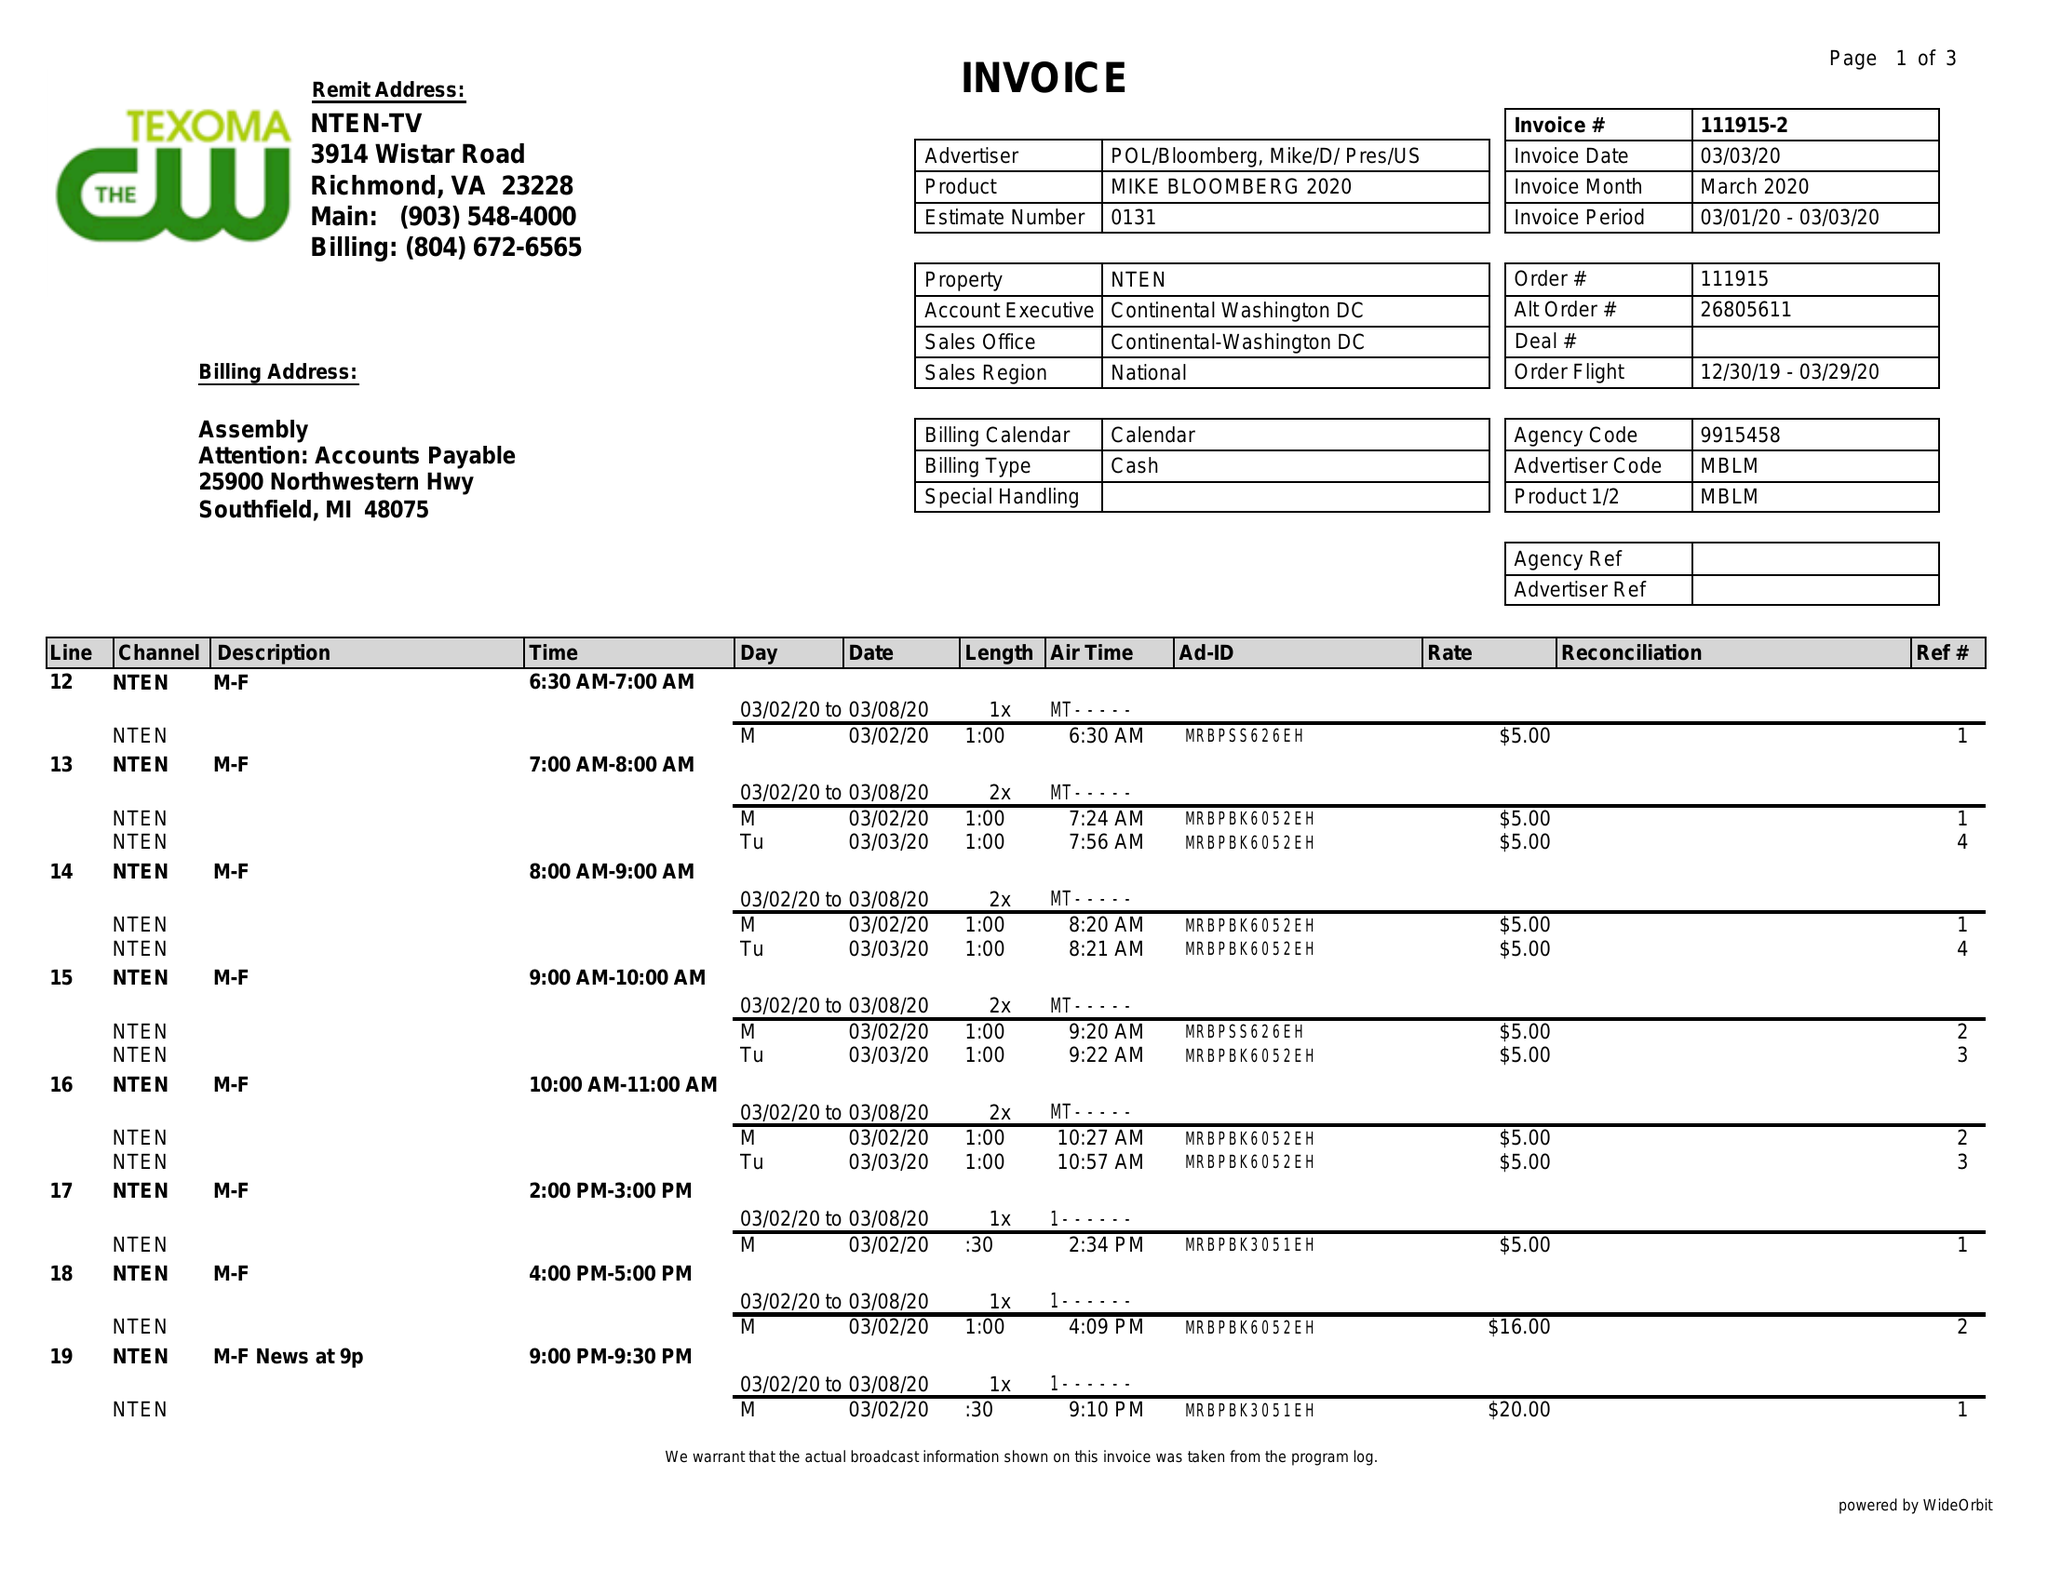What is the value for the advertiser?
Answer the question using a single word or phrase. POL/BLOOMBERG,MIKE/D/PRES/US 